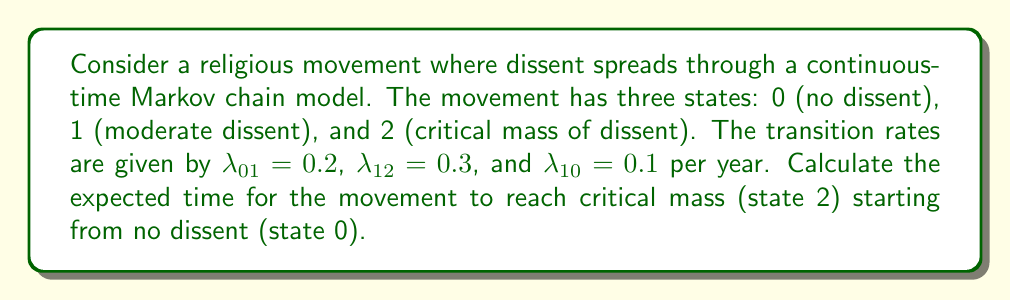Could you help me with this problem? To solve this problem, we'll use the concept of first passage time in continuous-time Markov chains.

Step 1: Define the mean first passage times
Let $\mu_i$ be the expected time to reach state 2 starting from state $i$.

Step 2: Set up the system of equations
For state 0: $\mu_0 = \frac{1}{\lambda_{01}} + \mu_1$
For state 1: $\mu_1 = \frac{1}{\lambda_{12} + \lambda_{10}} + \frac{\lambda_{10}}{\lambda_{12} + \lambda_{10}}\mu_0$

Step 3: Solve the system of equations
Substitute the equation for $\mu_1$ into the equation for $\mu_0$:

$\mu_0 = \frac{1}{\lambda_{01}} + \frac{1}{\lambda_{12} + \lambda_{10}} + \frac{\lambda_{10}}{\lambda_{12} + \lambda_{10}}\mu_0$

Step 4: Simplify and solve for $\mu_0$
$\mu_0 = \frac{1}{0.2} + \frac{1}{0.3 + 0.1} + \frac{0.1}{0.3 + 0.1}\mu_0$

$\mu_0 = 5 + 2.5 + 0.25\mu_0$

$0.75\mu_0 = 7.5$

$\mu_0 = 10$ years

Step 5: Interpret the result
The expected time for the dissenting movement to reach critical mass starting from no dissent is 10 years.
Answer: 10 years 